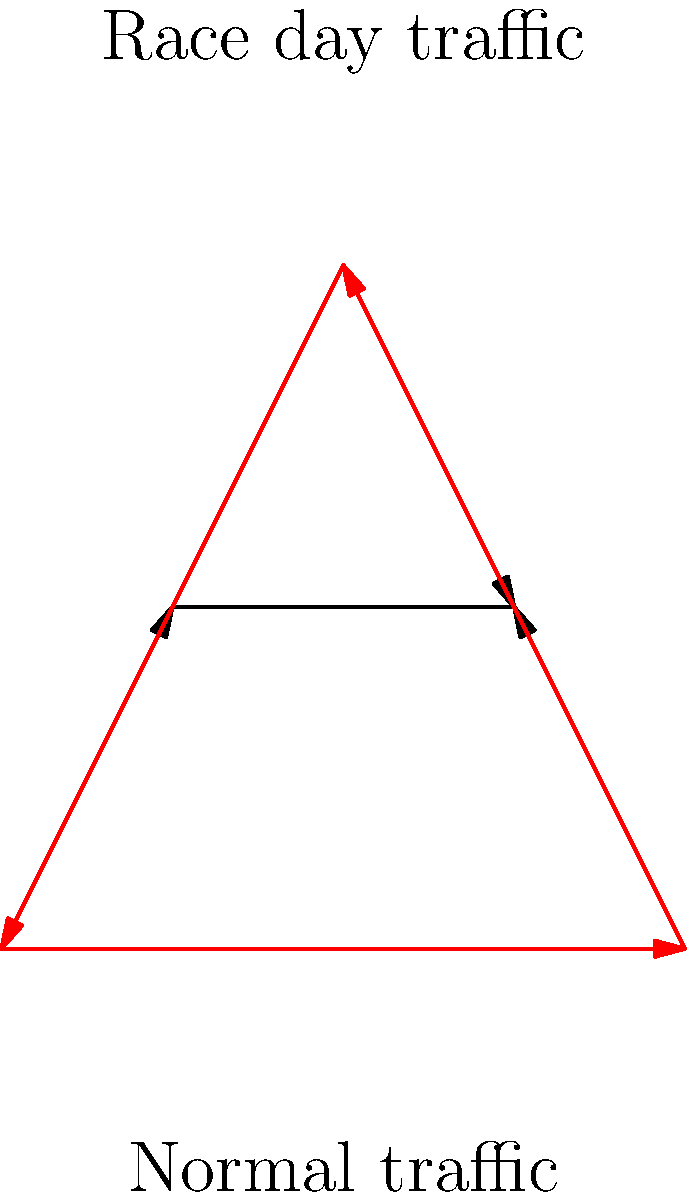Based on the traffic flow patterns shown in the diagram, which road segment experiences the most significant change in traffic direction during racing events compared to normal conditions? To determine the road segment with the most significant change in traffic direction, we need to compare the normal traffic flow with the race day traffic flow for each segment:

1. Segment AB:
   - Normal: No direct flow
   - Race day: Clockwise flow
   Change: Significant (from no flow to unidirectional)

2. Segment BC:
   - Normal: No direct flow
   - Race day: Clockwise flow
   Change: Significant (from no flow to unidirectional)

3. Segment CA:
   - Normal: No direct flow
   - Race day: Clockwise flow
   Change: Significant (from no flow to unidirectional)

4. Segment AD:
   - Normal: Inward flow
   - Race day: No direct flow
   Change: Moderate (from unidirectional to no flow)

5. Segment BE:
   - Normal: Inward flow
   - Race day: No direct flow
   Change: Moderate (from unidirectional to no flow)

6. Segment CE:
   - Normal: Inward flow
   - Race day: No direct flow
   Change: Moderate (from unidirectional to no flow)

7. Segment DE:
   - Normal: No clear flow direction
   - Race day: No clear flow direction
   Change: Minimal

The segments AB, BC, and CA all show a significant change from no direct flow to a unidirectional clockwise flow. However, these changes are part of a single circular route around the triangle. Therefore, we can consider the entire triangular route (AB-BC-CA) as the area experiencing the most significant change in traffic direction during racing events.
Answer: The triangular route AB-BC-CA 